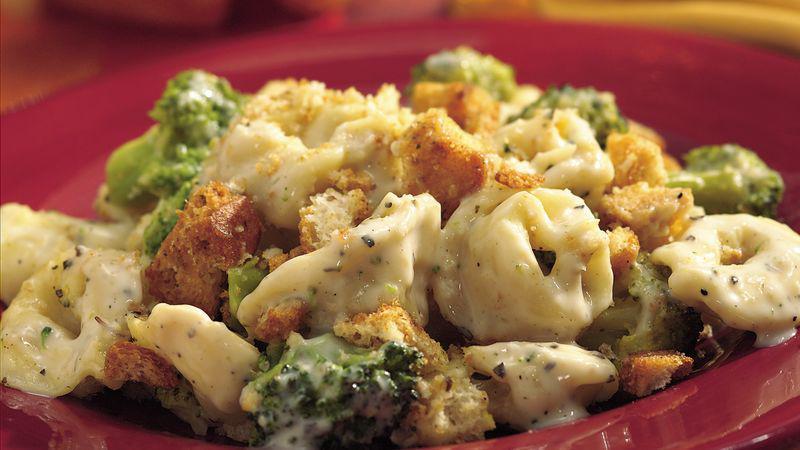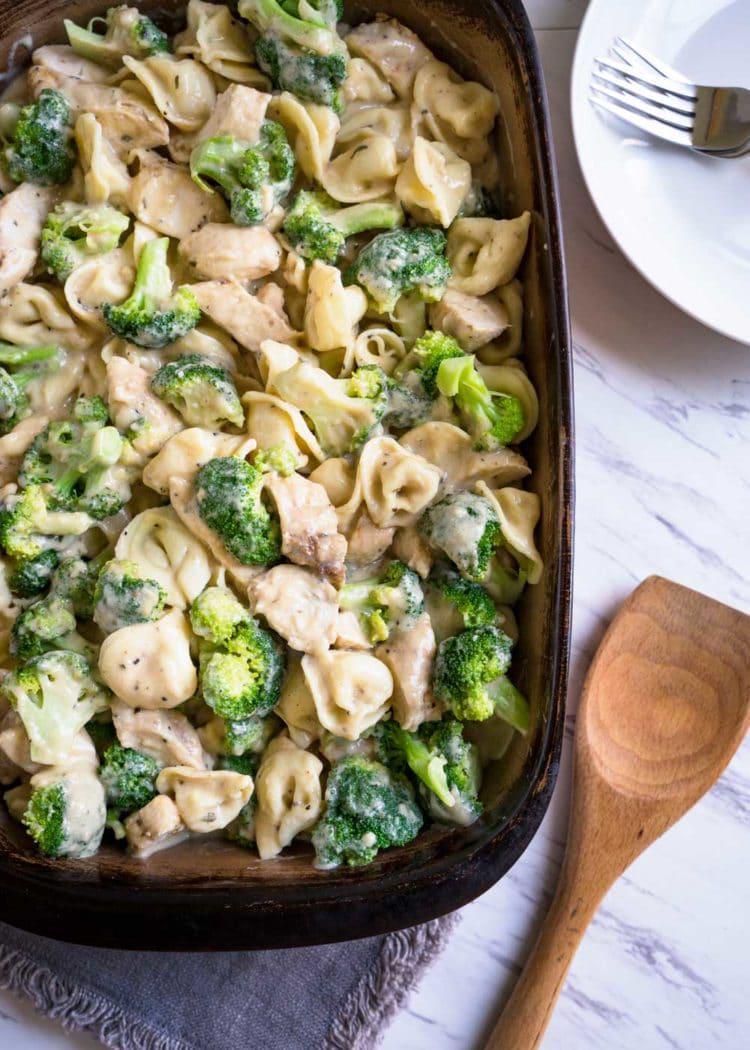The first image is the image on the left, the second image is the image on the right. Evaluate the accuracy of this statement regarding the images: "All broccoli dishes are served on white plates.". Is it true? Answer yes or no. No. 